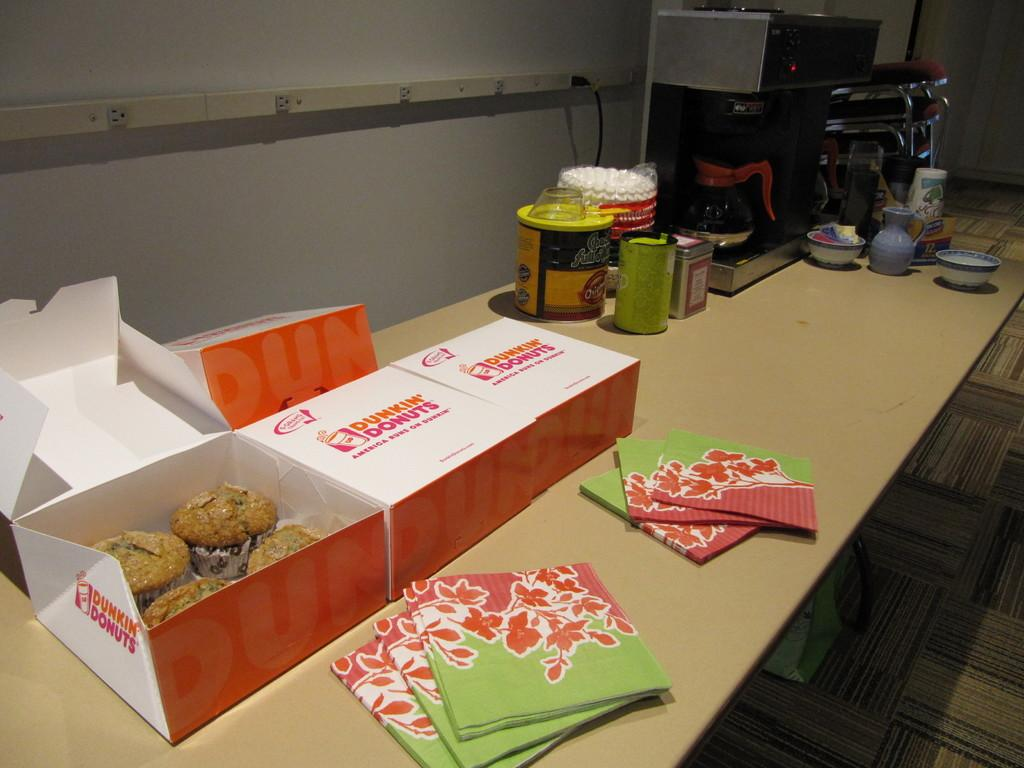<image>
Write a terse but informative summary of the picture. Several boxes of Dunkin Donuts muffins and some floral napkins in front of them. 